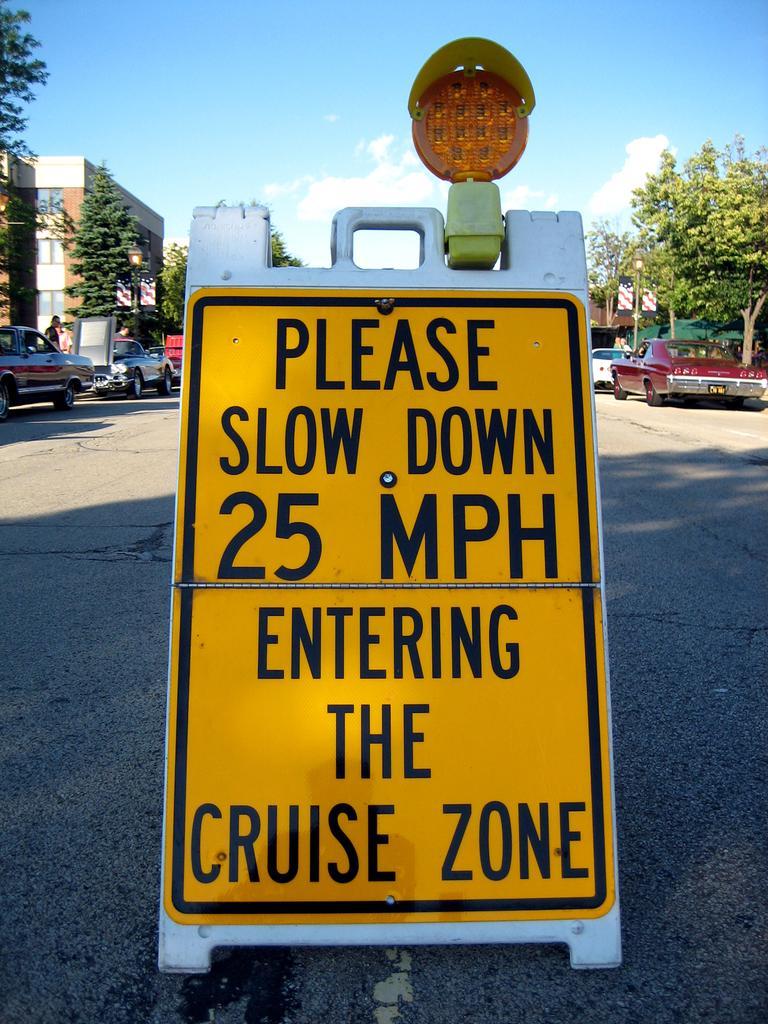Describe this image in one or two sentences. In this picture we can see a signboard and vehicles on the road. On the left and right side of the image, there are trees, street lights and buildings. At the top of the image, there is the sky. 